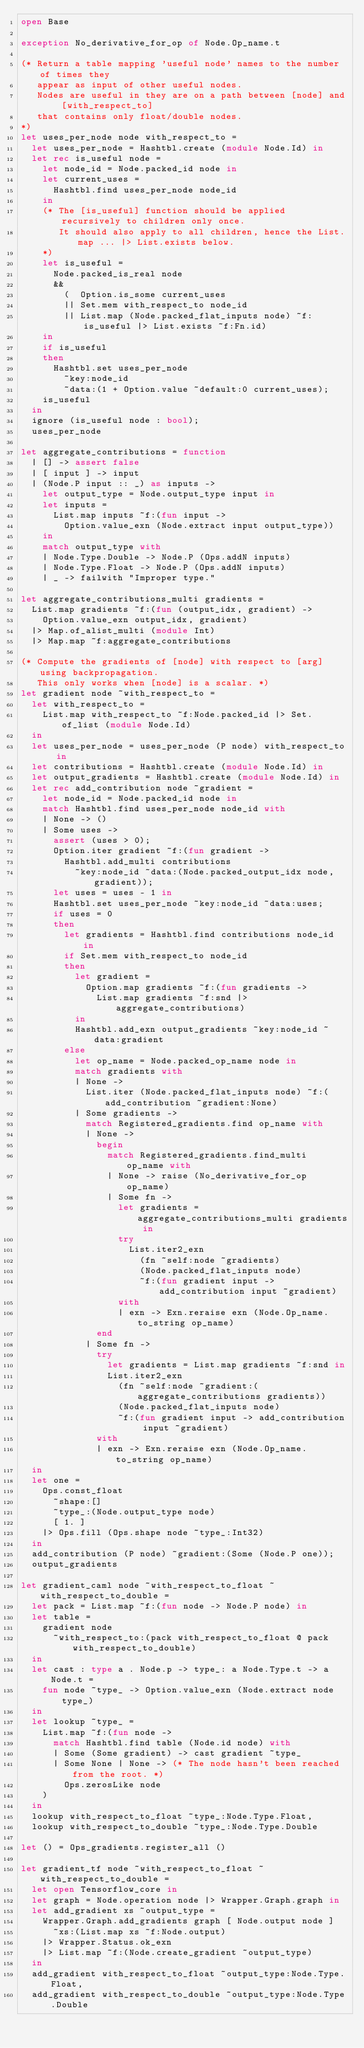Convert code to text. <code><loc_0><loc_0><loc_500><loc_500><_OCaml_>open Base

exception No_derivative_for_op of Node.Op_name.t

(* Return a table mapping 'useful node' names to the number of times they
   appear as input of other useful nodes.
   Nodes are useful in they are on a path between [node] and [with_respect_to]
   that contains only float/double nodes.
*)
let uses_per_node node with_respect_to =
  let uses_per_node = Hashtbl.create (module Node.Id) in
  let rec is_useful node =
    let node_id = Node.packed_id node in
    let current_uses =
      Hashtbl.find uses_per_node node_id
    in
    (* The [is_useful] function should be applied recursively to children only once.
       It should also apply to all children, hence the List.map ... |> List.exists below.
    *)
    let is_useful =
      Node.packed_is_real node
      &&
        (  Option.is_some current_uses
        || Set.mem with_respect_to node_id
        || List.map (Node.packed_flat_inputs node) ~f:is_useful |> List.exists ~f:Fn.id)
    in
    if is_useful
    then
      Hashtbl.set uses_per_node
        ~key:node_id
        ~data:(1 + Option.value ~default:0 current_uses);
    is_useful
  in
  ignore (is_useful node : bool);
  uses_per_node

let aggregate_contributions = function
  | [] -> assert false
  | [ input ] -> input
  | (Node.P input :: _) as inputs ->
    let output_type = Node.output_type input in
    let inputs =
      List.map inputs ~f:(fun input ->
        Option.value_exn (Node.extract input output_type))
    in
    match output_type with
    | Node.Type.Double -> Node.P (Ops.addN inputs)
    | Node.Type.Float -> Node.P (Ops.addN inputs)
    | _ -> failwith "Improper type."

let aggregate_contributions_multi gradients =
  List.map gradients ~f:(fun (output_idx, gradient) ->
    Option.value_exn output_idx, gradient)
  |> Map.of_alist_multi (module Int)
  |> Map.map ~f:aggregate_contributions

(* Compute the gradients of [node] with respect to [arg] using backpropagation.
   This only works when [node] is a scalar. *)
let gradient node ~with_respect_to =
  let with_respect_to =
    List.map with_respect_to ~f:Node.packed_id |> Set.of_list (module Node.Id)
  in
  let uses_per_node = uses_per_node (P node) with_respect_to in
  let contributions = Hashtbl.create (module Node.Id) in
  let output_gradients = Hashtbl.create (module Node.Id) in
  let rec add_contribution node ~gradient =
    let node_id = Node.packed_id node in
    match Hashtbl.find uses_per_node node_id with
    | None -> ()
    | Some uses ->
      assert (uses > 0);
      Option.iter gradient ~f:(fun gradient ->
        Hashtbl.add_multi contributions
          ~key:node_id ~data:(Node.packed_output_idx node, gradient));
      let uses = uses - 1 in
      Hashtbl.set uses_per_node ~key:node_id ~data:uses;
      if uses = 0
      then
        let gradients = Hashtbl.find contributions node_id in
        if Set.mem with_respect_to node_id
        then
          let gradient =
            Option.map gradients ~f:(fun gradients ->
              List.map gradients ~f:snd |> aggregate_contributions)
          in
          Hashtbl.add_exn output_gradients ~key:node_id ~data:gradient
        else
          let op_name = Node.packed_op_name node in
          match gradients with
          | None ->
            List.iter (Node.packed_flat_inputs node) ~f:(add_contribution ~gradient:None)
          | Some gradients ->
            match Registered_gradients.find op_name with
            | None ->
              begin
                match Registered_gradients.find_multi op_name with
                | None -> raise (No_derivative_for_op op_name)
                | Some fn ->
                  let gradients = aggregate_contributions_multi gradients in
                  try
                    List.iter2_exn
                      (fn ~self:node ~gradients)
                      (Node.packed_flat_inputs node)
                      ~f:(fun gradient input -> add_contribution input ~gradient)
                  with
                  | exn -> Exn.reraise exn (Node.Op_name.to_string op_name)
              end
            | Some fn ->
              try
                let gradients = List.map gradients ~f:snd in
                List.iter2_exn
                  (fn ~self:node ~gradient:(aggregate_contributions gradients))
                  (Node.packed_flat_inputs node)
                  ~f:(fun gradient input -> add_contribution input ~gradient)
              with
              | exn -> Exn.reraise exn (Node.Op_name.to_string op_name)
  in
  let one =
    Ops.const_float
      ~shape:[]
      ~type_:(Node.output_type node)
      [ 1. ]
    |> Ops.fill (Ops.shape node ~type_:Int32)
  in
  add_contribution (P node) ~gradient:(Some (Node.P one));
  output_gradients

let gradient_caml node ~with_respect_to_float ~with_respect_to_double =
  let pack = List.map ~f:(fun node -> Node.P node) in
  let table =
    gradient node
      ~with_respect_to:(pack with_respect_to_float @ pack with_respect_to_double)
  in
  let cast : type a . Node.p -> type_: a Node.Type.t -> a Node.t =
    fun node ~type_ -> Option.value_exn (Node.extract node type_)
  in
  let lookup ~type_ =
    List.map ~f:(fun node ->
      match Hashtbl.find table (Node.id node) with
      | Some (Some gradient) -> cast gradient ~type_
      | Some None | None -> (* The node hasn't been reached from the root. *)
        Ops.zerosLike node
    )
  in
  lookup with_respect_to_float ~type_:Node.Type.Float,
  lookup with_respect_to_double ~type_:Node.Type.Double

let () = Ops_gradients.register_all ()

let gradient_tf node ~with_respect_to_float ~with_respect_to_double =
  let open Tensorflow_core in
  let graph = Node.operation node |> Wrapper.Graph.graph in
  let add_gradient xs ~output_type =
    Wrapper.Graph.add_gradients graph [ Node.output node ]
      ~xs:(List.map xs ~f:Node.output)
    |> Wrapper.Status.ok_exn
    |> List.map ~f:(Node.create_gradient ~output_type)
  in
  add_gradient with_respect_to_float ~output_type:Node.Type.Float,
  add_gradient with_respect_to_double ~output_type:Node.Type.Double
</code> 